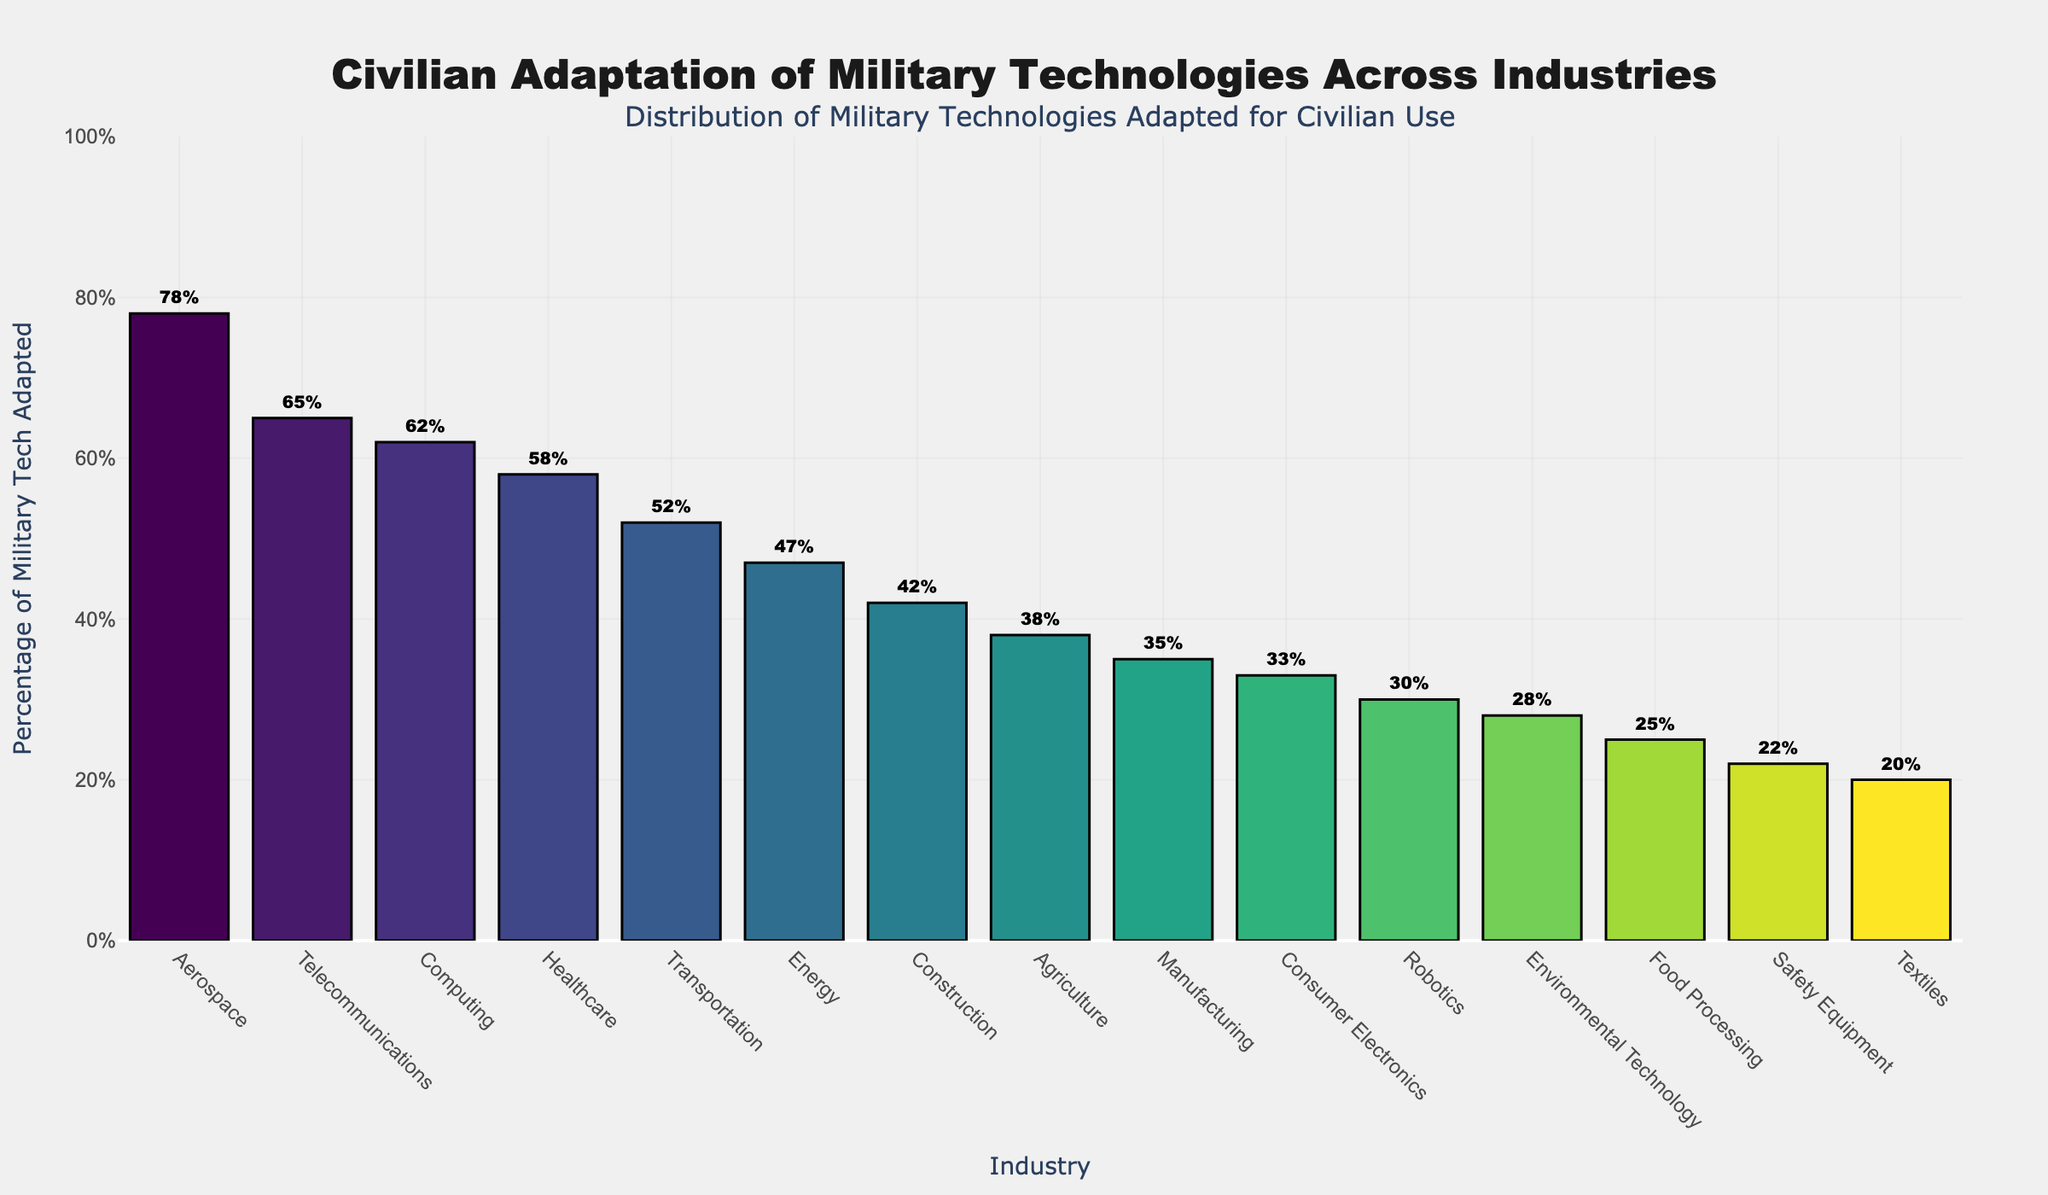What industry has the highest percentage of military technology adapted for civilian use? The tallest bar represents the industry with the highest percentage of military technology adapted for civilian use. In the chart, the Aerospace bar is the tallest with a percentage of 78%.
Answer: Aerospace What two industries have the closest percentages of military technology adaptation, and what are those percentages? By examining the lengths of the bars, the Agriculture and Manufacturing industries have the closest percentages. Agriculture is at 38%, and Manufacturing is at 35%, so the difference is 3%.
Answer: Agriculture (38%) and Manufacturing (35%) Which industry has the lowest percentage of military technology adapted for civilian use, and what is the percentage? The shortest bar indicates the industry with the lowest percentage. In this case, Textiles is the shortest with 20%.
Answer: Textiles (20%) By how much does the percentage of military technology adapted in Healthcare exceed that of Robotics? The height difference between the Healthcare and Robotics bars shows the excess. Healthcare is at 58%, and Robotics is at 30%. The difference is 58% - 30% = 28%.
Answer: 28% What is the sum of the percentages of military technology adapted by the Telecom and Computing industries? Adding the Telecom percentage (65%) and the Computing percentage (62%) yields: 65 + 62 = 127.
Answer: 127% Which three industries follow Aerospace in terms of the highest percentages of military technology adaptation? The next three tallest bars after Aerospace represent the top-following industries. They are Telecommunications (65%), Computing (62%), and Healthcare (58%).
Answer: Telecommunications, Computing, Healthcare What's the average percentage of military technology adapted for civilian use across the Construction, Manufacturing, and Consumer Electronics industries? Sum their percentages: Construction (42%), Manufacturing (35%), Consumer Electronics (33%). Sum: 42 + 35 + 33 = 110. Average: 110 / 3 ≈ 36.67%.
Answer: 36.67% Which industry is closer to having 50% adaptation, Energy or Transportation? Transportation is at 52%, which is closer to 50% compared to Energy at 47%.
Answer: Transportation What is the difference in percentage between the Aerospace and Consumer Electronics industries? Subtract the percentage of Consumer Electronics (33%) from Aerospace (78%). 78 - 33 = 45.
Answer: 45% Does the Environmental Technology industry have a percentage higher or lower than 30%? The bar height for Environmental Technology is slightly below the 30% mark, indicating it is lower. It has a percentage of 28%.
Answer: Lower 